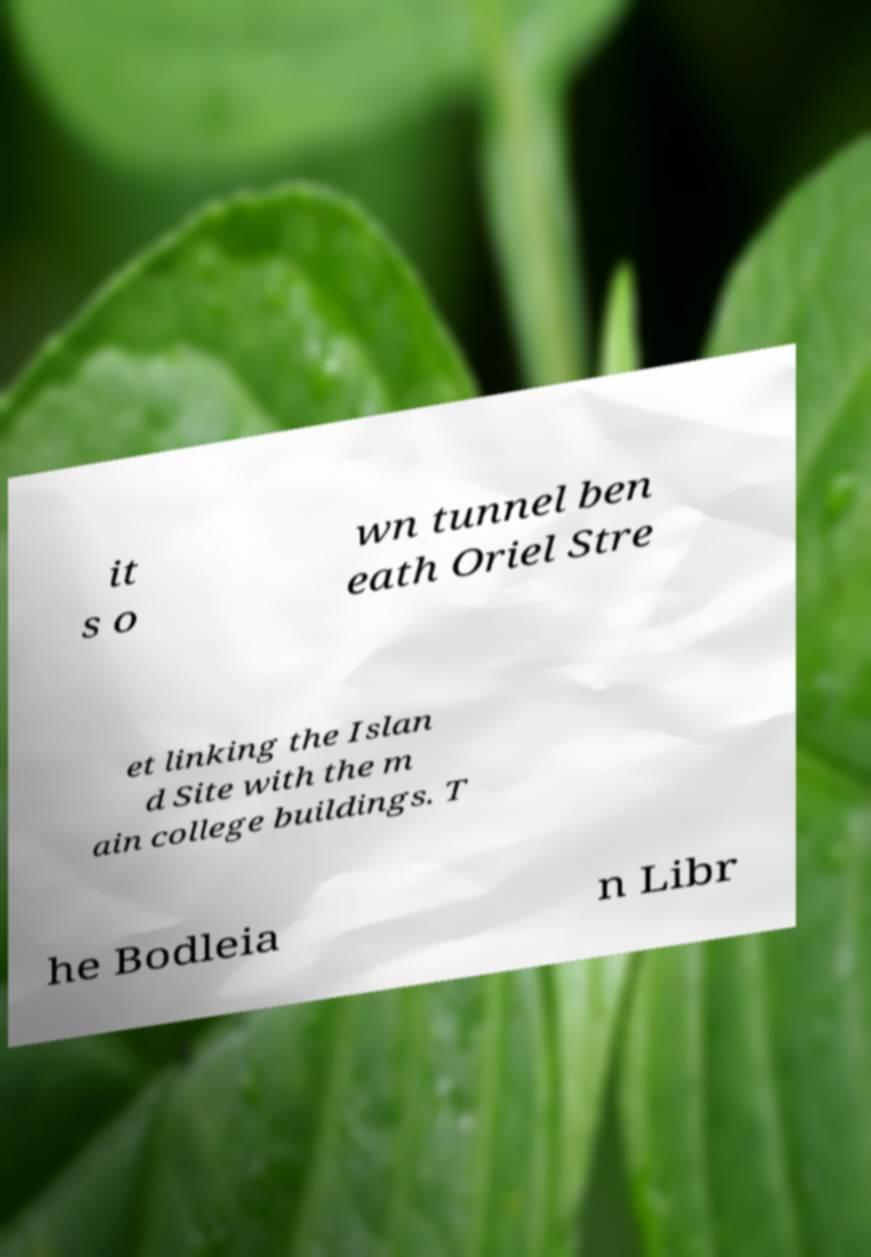I need the written content from this picture converted into text. Can you do that? it s o wn tunnel ben eath Oriel Stre et linking the Islan d Site with the m ain college buildings. T he Bodleia n Libr 